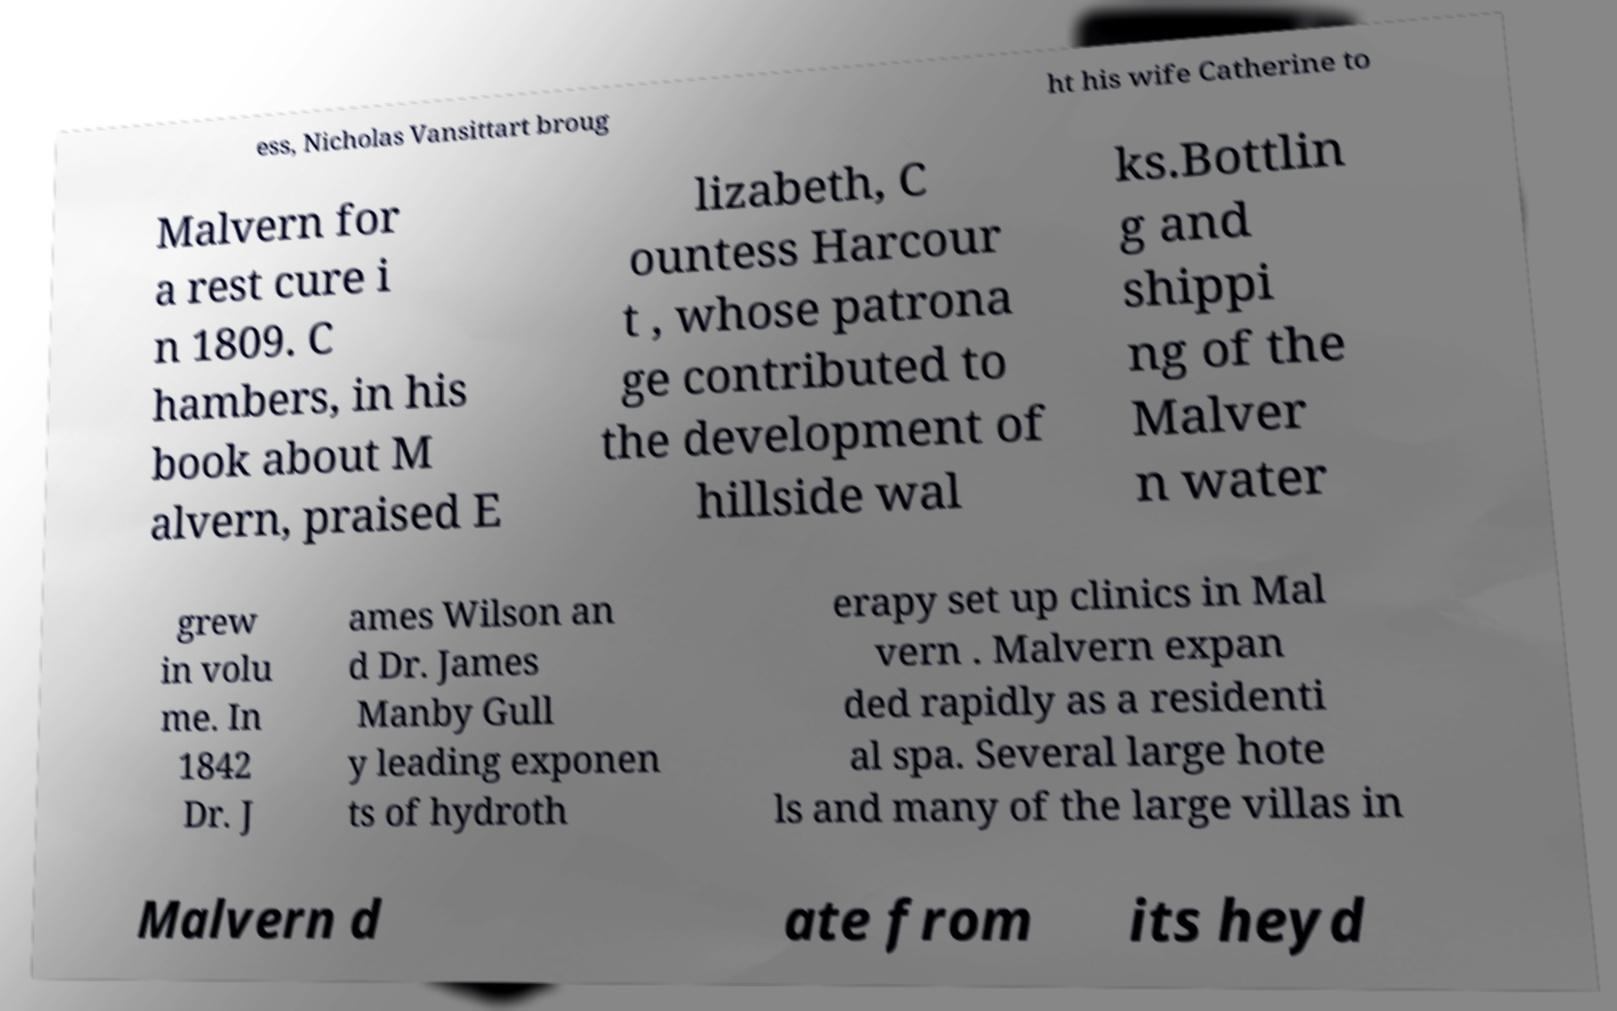Can you accurately transcribe the text from the provided image for me? ess, Nicholas Vansittart broug ht his wife Catherine to Malvern for a rest cure i n 1809. C hambers, in his book about M alvern, praised E lizabeth, C ountess Harcour t , whose patrona ge contributed to the development of hillside wal ks.Bottlin g and shippi ng of the Malver n water grew in volu me. In 1842 Dr. J ames Wilson an d Dr. James Manby Gull y leading exponen ts of hydroth erapy set up clinics in Mal vern . Malvern expan ded rapidly as a residenti al spa. Several large hote ls and many of the large villas in Malvern d ate from its heyd 